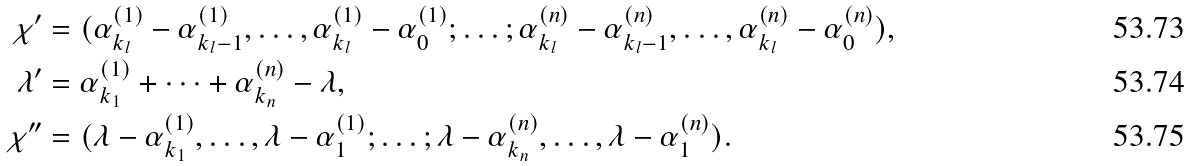<formula> <loc_0><loc_0><loc_500><loc_500>\chi ^ { \prime } & = ( \alpha _ { k _ { l } } ^ { ( 1 ) } - \alpha _ { k _ { l } - 1 } ^ { ( 1 ) } , \dots , \alpha _ { k _ { l } } ^ { ( 1 ) } - \alpha _ { 0 } ^ { ( 1 ) } ; \dots ; \alpha _ { k _ { l } } ^ { ( n ) } - \alpha _ { k _ { l } - 1 } ^ { ( n ) } , \dots , \alpha _ { k _ { l } } ^ { ( n ) } - \alpha _ { 0 } ^ { ( n ) } ) , \\ \lambda ^ { \prime } & = \alpha _ { k _ { 1 } } ^ { ( 1 ) } + \dots + \alpha _ { k _ { n } } ^ { ( n ) } - \lambda , \\ \chi ^ { \prime \prime } & = ( \lambda - \alpha _ { k _ { 1 } } ^ { ( 1 ) } , \dots , \lambda - \alpha _ { 1 } ^ { ( 1 ) } ; \dots ; \lambda - \alpha _ { k _ { n } } ^ { ( n ) } , \dots , \lambda - \alpha _ { 1 } ^ { ( n ) } ) .</formula> 